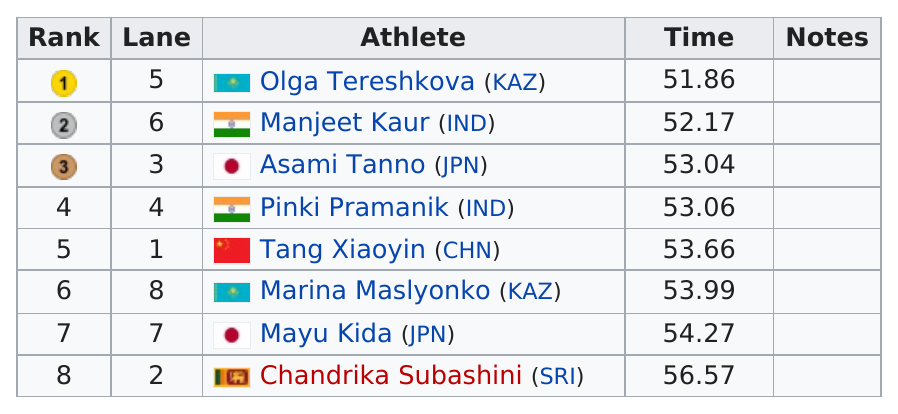Point out several critical features in this image. The number of athletes from Japan is 2. Asami Tanno placed after Manjeet Kaur. The fifth place finisher completed the race in 53.66 minutes. Out of the athletes who finished, 2 of them had a time less than 53.00. Mangeet Kaur has a very long time of 52 hours and 17 minutes. 